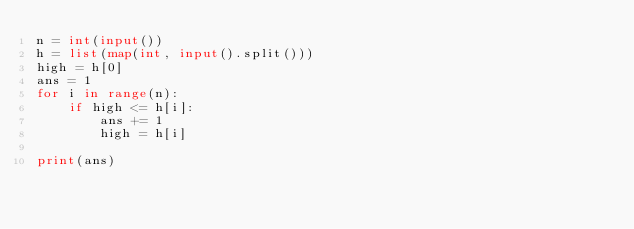Convert code to text. <code><loc_0><loc_0><loc_500><loc_500><_Python_>n = int(input())
h = list(map(int, input().split()))
high = h[0]
ans = 1
for i in range(n):
    if high <= h[i]:
        ans += 1
        high = h[i]

print(ans)</code> 